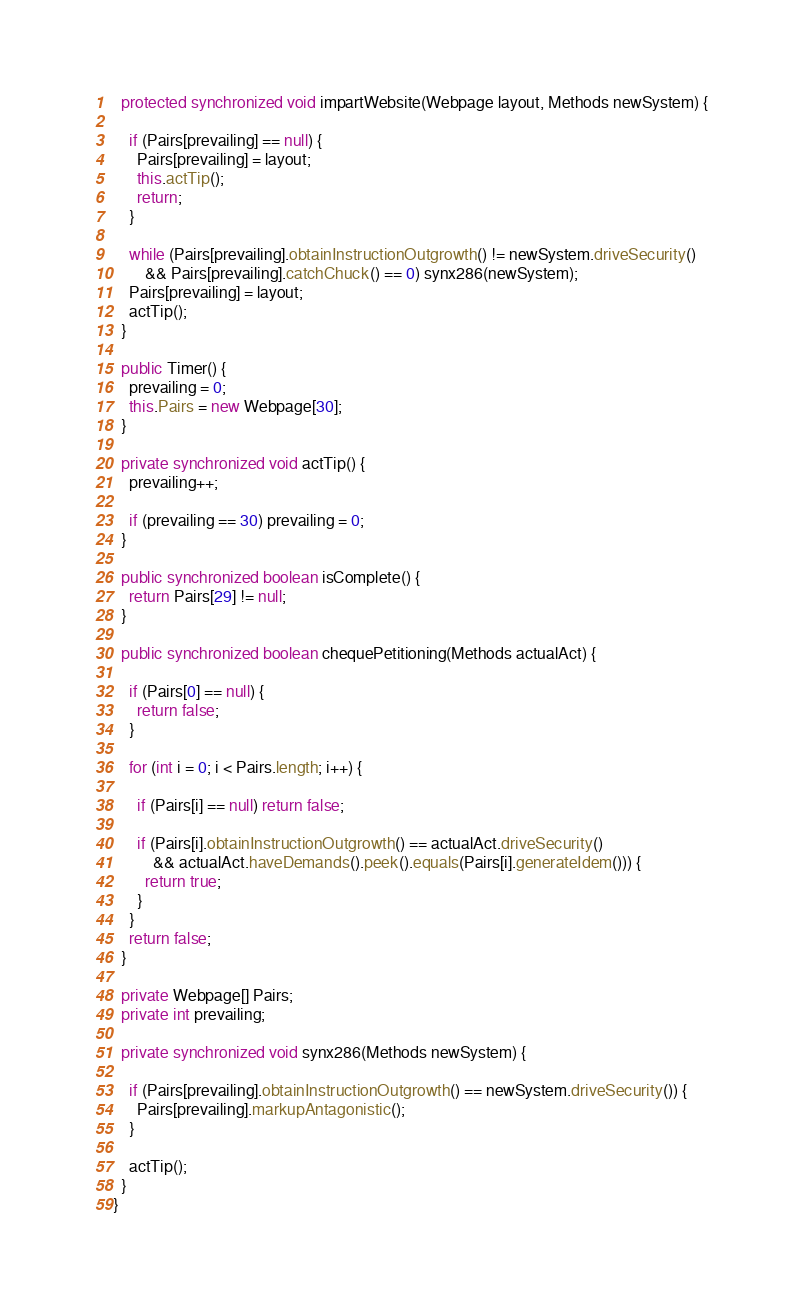<code> <loc_0><loc_0><loc_500><loc_500><_Java_>  protected synchronized void impartWebsite(Webpage layout, Methods newSystem) {

    if (Pairs[prevailing] == null) {
      Pairs[prevailing] = layout;
      this.actTip();
      return;
    }

    while (Pairs[prevailing].obtainInstructionOutgrowth() != newSystem.driveSecurity()
        && Pairs[prevailing].catchChuck() == 0) synx286(newSystem);
    Pairs[prevailing] = layout;
    actTip();
  }

  public Timer() {
    prevailing = 0;
    this.Pairs = new Webpage[30];
  }

  private synchronized void actTip() {
    prevailing++;

    if (prevailing == 30) prevailing = 0;
  }

  public synchronized boolean isComplete() {
    return Pairs[29] != null;
  }

  public synchronized boolean chequePetitioning(Methods actualAct) {

    if (Pairs[0] == null) {
      return false;
    }

    for (int i = 0; i < Pairs.length; i++) {

      if (Pairs[i] == null) return false;

      if (Pairs[i].obtainInstructionOutgrowth() == actualAct.driveSecurity()
          && actualAct.haveDemands().peek().equals(Pairs[i].generateIdem())) {
        return true;
      }
    }
    return false;
  }

  private Webpage[] Pairs;
  private int prevailing;

  private synchronized void synx286(Methods newSystem) {

    if (Pairs[prevailing].obtainInstructionOutgrowth() == newSystem.driveSecurity()) {
      Pairs[prevailing].markupAntagonistic();
    }

    actTip();
  }
}
</code> 